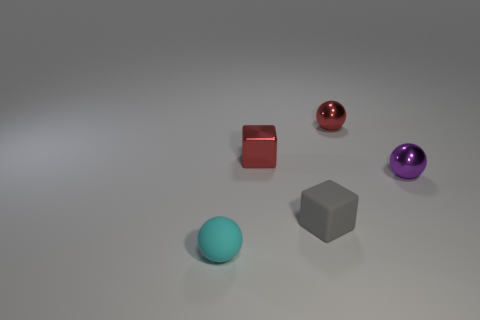How many other things are there of the same material as the small red cube?
Provide a succinct answer. 2. How big is the metallic sphere that is to the right of the red metal ball?
Your response must be concise. Small. There is a small red object on the right side of the small gray rubber object; does it have the same shape as the cyan matte thing?
Your answer should be very brief. Yes. What material is the other thing that is the same shape as the gray object?
Keep it short and to the point. Metal. Is there any other thing that is the same size as the gray block?
Your answer should be very brief. Yes. Are there any blue shiny cylinders?
Offer a very short reply. No. What material is the small ball behind the small shiny object in front of the red metal thing that is on the left side of the tiny red sphere made of?
Offer a terse response. Metal. Does the purple object have the same shape as the red object on the left side of the gray thing?
Ensure brevity in your answer.  No. How many small cyan matte things have the same shape as the gray thing?
Provide a short and direct response. 0. The small purple object is what shape?
Make the answer very short. Sphere. 